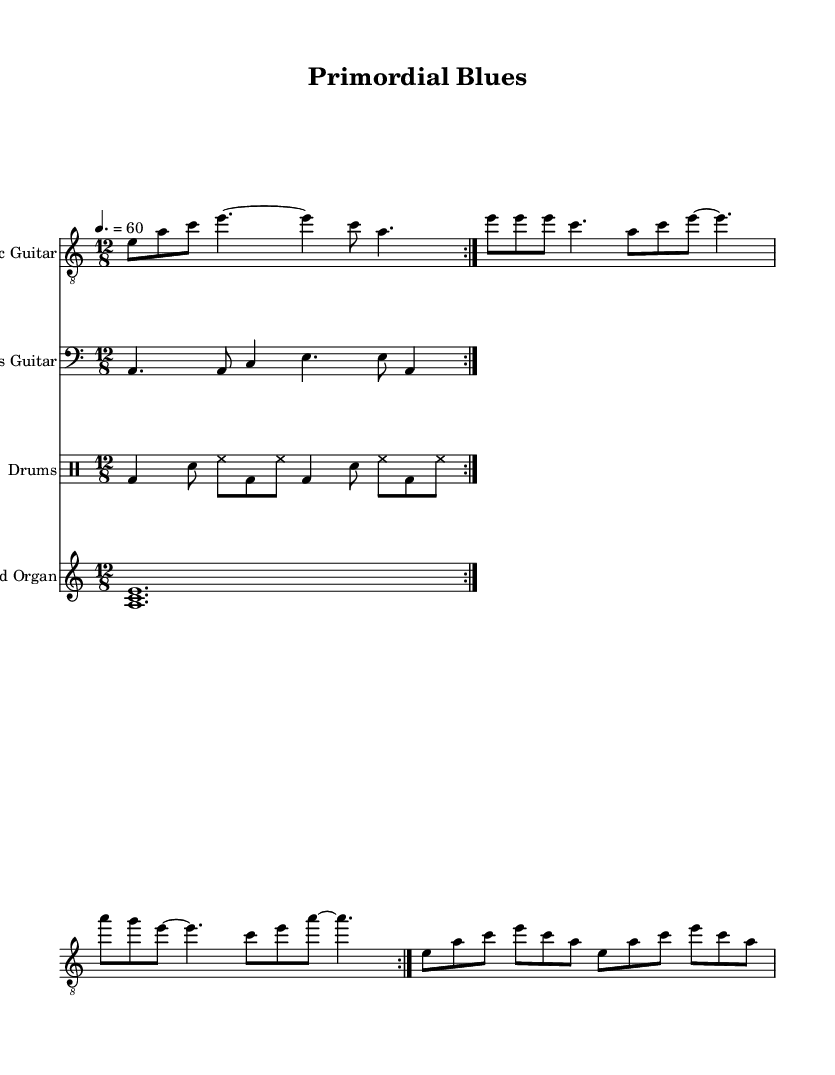What is the key signature of this music? The key signature is A minor, which is indicated by the absence of sharps or flats in the music. A minor is the relative minor of C major, and it is common in electric blues.
Answer: A minor What is the time signature of this music? The time signature is 12/8, which means there are 12 eighth-note beats in each measure. This is typical for a slow, contemplative blues feel.
Answer: 12/8 What is the tempo marking in this score? The tempo marking is 60 beats per minute, indicated by the metronome marking of 4 = 60. This slow tempo sets a laid-back mood suitable for the genre.
Answer: 60 How many times does the electric guitar part repeat in the score? The electric guitar part is marked to repeat volta 2, which means it will play through the section twice. This repetition is a common feature in blues music, enhancing the mood and feel.
Answer: 2 What instrument plays a sustained chord throughout the piece? The Hammond organ plays a sustained chord, indicated by the chord <a c e> in a long note value (1. or whole note). This adds to the contemplative ambiance of the music.
Answer: Hammond organ How does the bass guitar interact with the electric guitar? The bass guitar provides a steady rhythm and complements the electric guitar with a simpler melodic line, maintaining the groove typical of blues music. This interaction creates a supportive harmonic foundation.
Answer: Supports harmonically What type of drum pattern is used in this piece? The drum pattern consists of a basic blues beat with bass drum, snare, and hi-hat, repeated throughout the piece. It serves to keep the rhythm steady and engage the listener.
Answer: Basic blues beat 